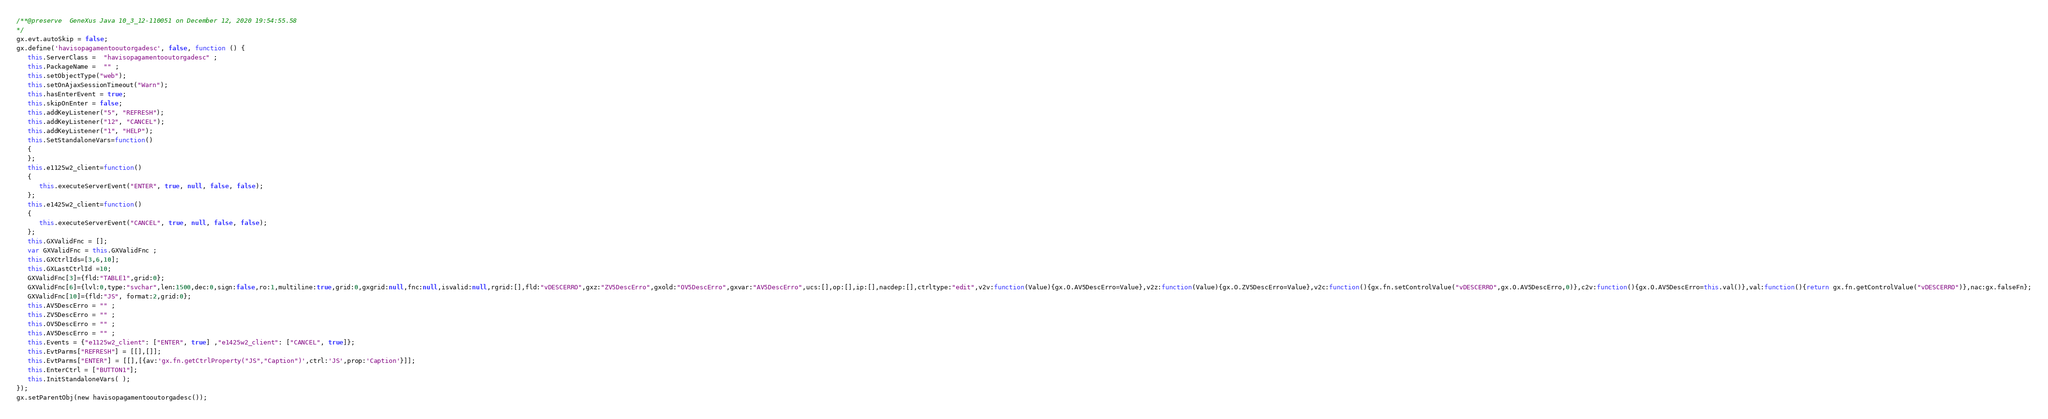<code> <loc_0><loc_0><loc_500><loc_500><_JavaScript_>/**@preserve  GeneXus Java 10_3_12-110051 on December 12, 2020 19:54:55.58
*/
gx.evt.autoSkip = false;
gx.define('havisopagamentooutorgadesc', false, function () {
   this.ServerClass =  "havisopagamentooutorgadesc" ;
   this.PackageName =  "" ;
   this.setObjectType("web");
   this.setOnAjaxSessionTimeout("Warn");
   this.hasEnterEvent = true;
   this.skipOnEnter = false;
   this.addKeyListener("5", "REFRESH");
   this.addKeyListener("12", "CANCEL");
   this.addKeyListener("1", "HELP");
   this.SetStandaloneVars=function()
   {
   };
   this.e1125w2_client=function()
   {
      this.executeServerEvent("ENTER", true, null, false, false);
   };
   this.e1425w2_client=function()
   {
      this.executeServerEvent("CANCEL", true, null, false, false);
   };
   this.GXValidFnc = [];
   var GXValidFnc = this.GXValidFnc ;
   this.GXCtrlIds=[3,6,10];
   this.GXLastCtrlId =10;
   GXValidFnc[3]={fld:"TABLE1",grid:0};
   GXValidFnc[6]={lvl:0,type:"svchar",len:1500,dec:0,sign:false,ro:1,multiline:true,grid:0,gxgrid:null,fnc:null,isvalid:null,rgrid:[],fld:"vDESCERRO",gxz:"ZV5DescErro",gxold:"OV5DescErro",gxvar:"AV5DescErro",ucs:[],op:[],ip:[],nacdep:[],ctrltype:"edit",v2v:function(Value){gx.O.AV5DescErro=Value},v2z:function(Value){gx.O.ZV5DescErro=Value},v2c:function(){gx.fn.setControlValue("vDESCERRO",gx.O.AV5DescErro,0)},c2v:function(){gx.O.AV5DescErro=this.val()},val:function(){return gx.fn.getControlValue("vDESCERRO")},nac:gx.falseFn};
   GXValidFnc[10]={fld:"JS", format:2,grid:0};
   this.AV5DescErro = "" ;
   this.ZV5DescErro = "" ;
   this.OV5DescErro = "" ;
   this.AV5DescErro = "" ;
   this.Events = {"e1125w2_client": ["ENTER", true] ,"e1425w2_client": ["CANCEL", true]};
   this.EvtParms["REFRESH"] = [[],[]];
   this.EvtParms["ENTER"] = [[],[{av:'gx.fn.getCtrlProperty("JS","Caption")',ctrl:'JS',prop:'Caption'}]];
   this.EnterCtrl = ["BUTTON1"];
   this.InitStandaloneVars( );
});
gx.setParentObj(new havisopagamentooutorgadesc());
</code> 